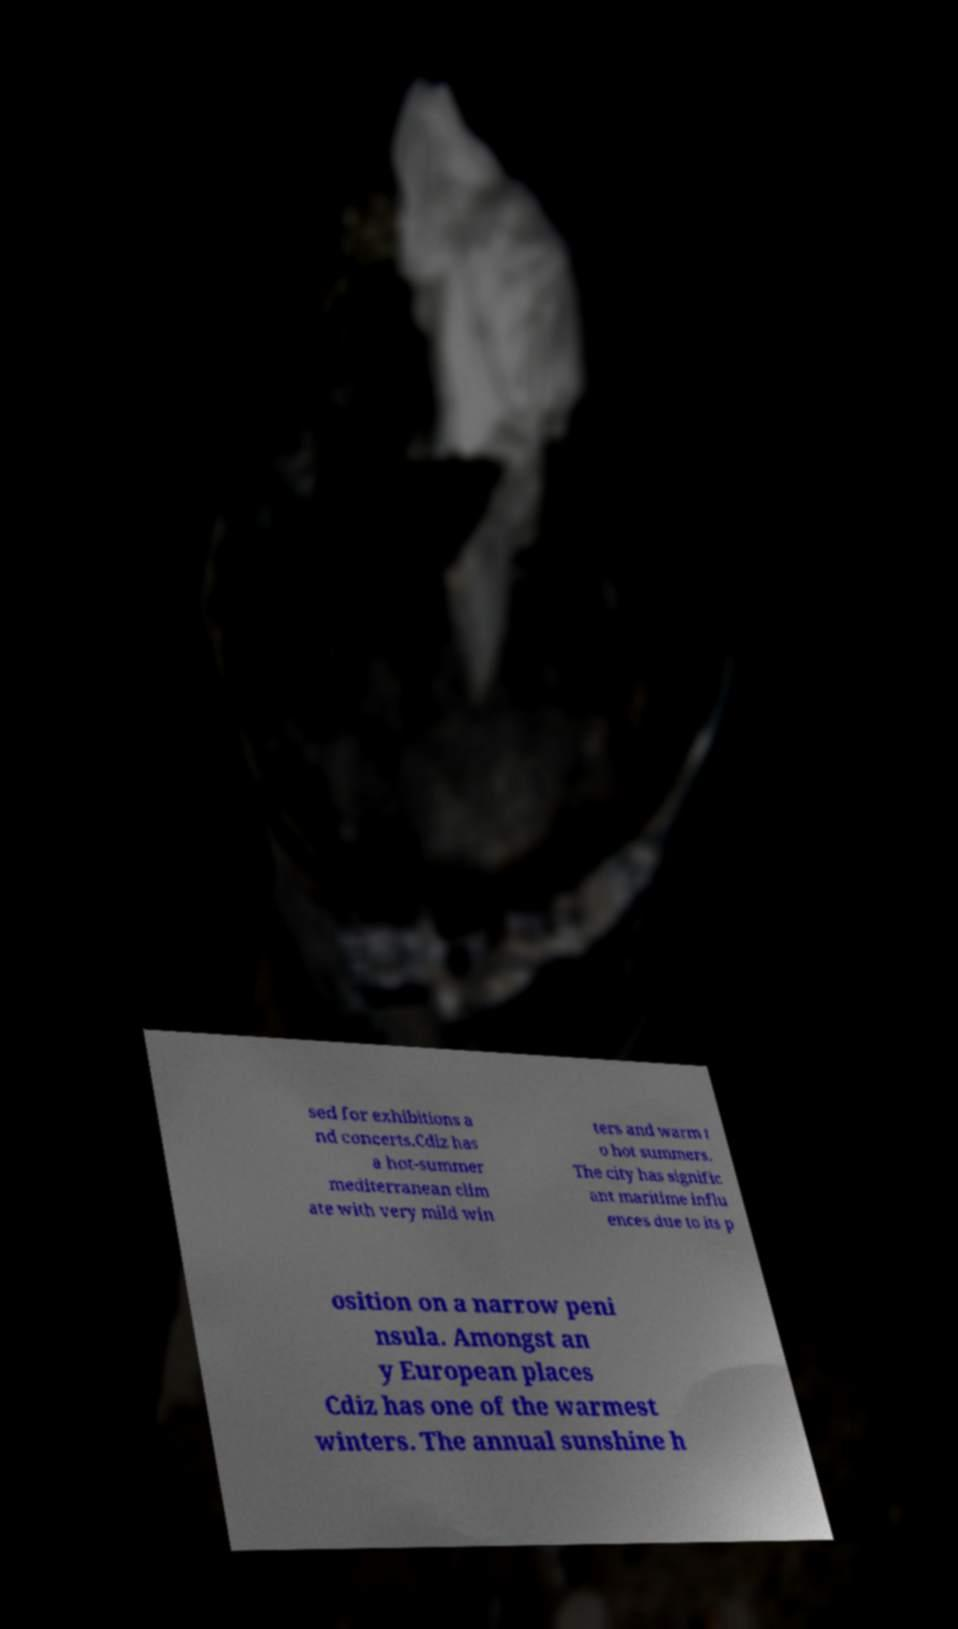Could you assist in decoding the text presented in this image and type it out clearly? sed for exhibitions a nd concerts.Cdiz has a hot-summer mediterranean clim ate with very mild win ters and warm t o hot summers. The city has signific ant maritime influ ences due to its p osition on a narrow peni nsula. Amongst an y European places Cdiz has one of the warmest winters. The annual sunshine h 